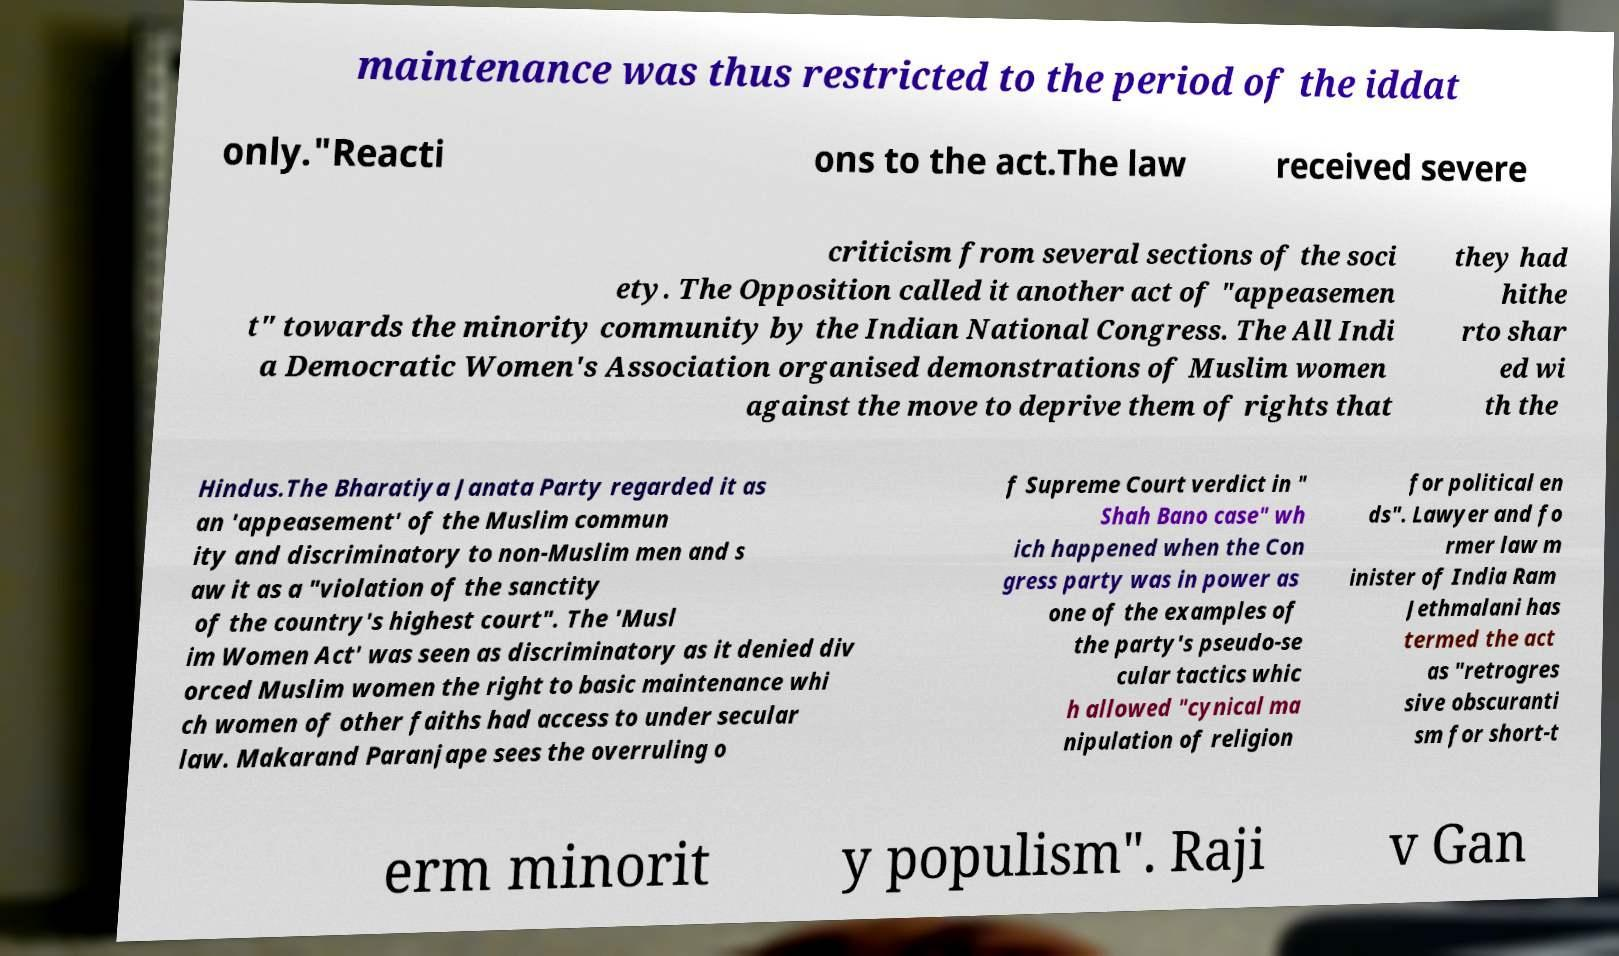Please identify and transcribe the text found in this image. maintenance was thus restricted to the period of the iddat only."Reacti ons to the act.The law received severe criticism from several sections of the soci ety. The Opposition called it another act of "appeasemen t" towards the minority community by the Indian National Congress. The All Indi a Democratic Women's Association organised demonstrations of Muslim women against the move to deprive them of rights that they had hithe rto shar ed wi th the Hindus.The Bharatiya Janata Party regarded it as an 'appeasement' of the Muslim commun ity and discriminatory to non-Muslim men and s aw it as a "violation of the sanctity of the country's highest court". The 'Musl im Women Act' was seen as discriminatory as it denied div orced Muslim women the right to basic maintenance whi ch women of other faiths had access to under secular law. Makarand Paranjape sees the overruling o f Supreme Court verdict in " Shah Bano case" wh ich happened when the Con gress party was in power as one of the examples of the party's pseudo-se cular tactics whic h allowed "cynical ma nipulation of religion for political en ds". Lawyer and fo rmer law m inister of India Ram Jethmalani has termed the act as "retrogres sive obscuranti sm for short-t erm minorit y populism". Raji v Gan 